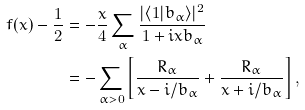<formula> <loc_0><loc_0><loc_500><loc_500>f ( x ) - \frac { 1 } { 2 } & = - \frac { x } { 4 } \sum _ { \alpha } \frac { | \langle 1 | b _ { \alpha } \rangle | ^ { 2 } } { 1 + i x b _ { \alpha } } \\ & = - \sum _ { \alpha > 0 } \left [ \frac { R _ { \alpha } } { x - i / b _ { \alpha } } + \frac { R _ { \alpha } } { x + i / b _ { \alpha } } \right ] ,</formula> 